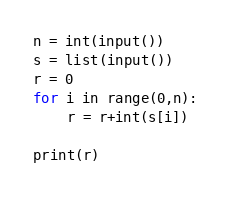<code> <loc_0><loc_0><loc_500><loc_500><_Python_>n = int(input())
s = list(input())
r = 0
for i in range(0,n):
    r = r+int(s[i])
    
print(r)</code> 